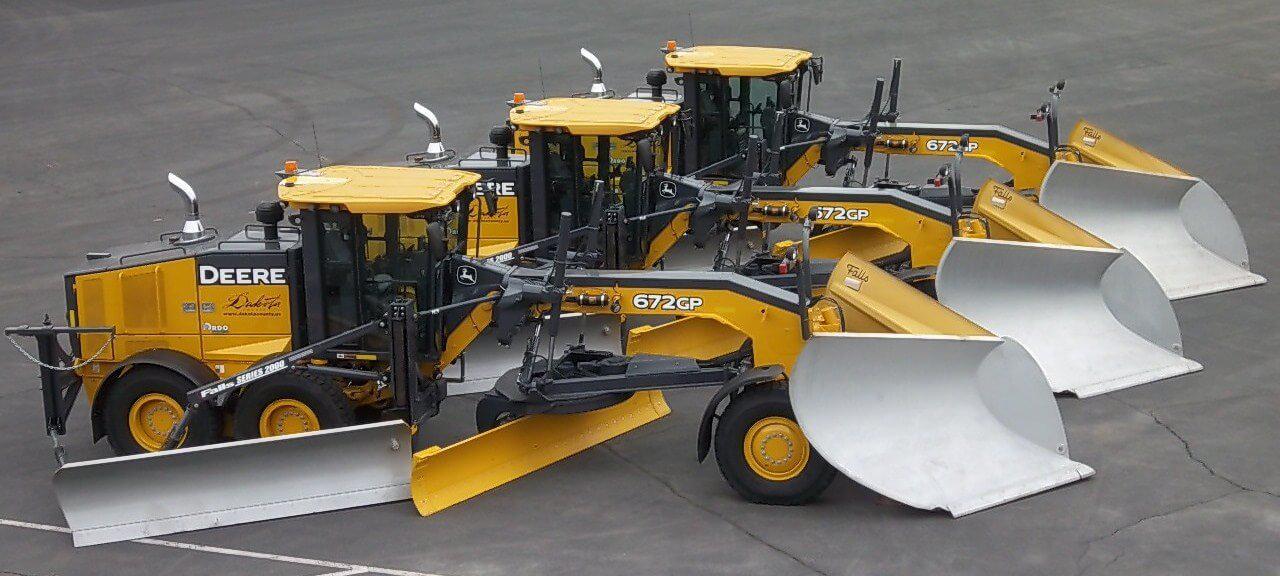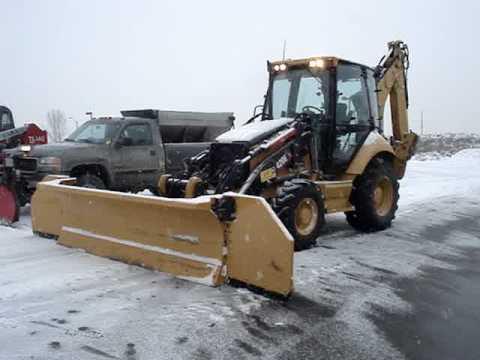The first image is the image on the left, the second image is the image on the right. Assess this claim about the two images: "The left and right image contains the same number of yellow snow plows.". Correct or not? Answer yes or no. No. 